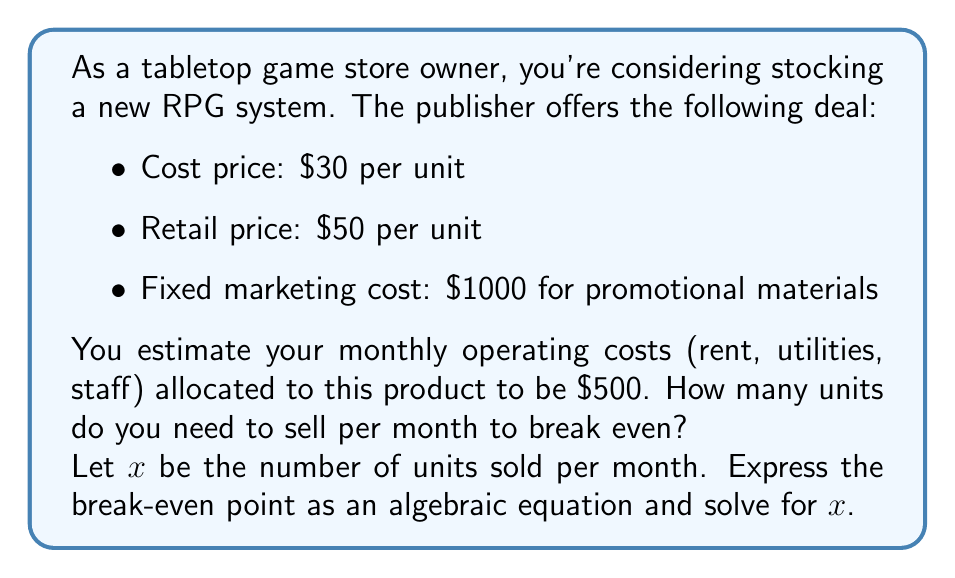Provide a solution to this math problem. To solve this problem, we need to set up an equation where total revenue equals total costs. Let's break it down step-by-step:

1. Revenue: 
   - Revenue per unit = $50
   - Total revenue = $50x$

2. Costs:
   - Variable cost per unit = $30
   - Total variable cost = $30x$
   - Fixed costs = $1000 (marketing) + $500 (monthly operating) = $1500$
   - Total costs = $30x + 1500$

3. Break-even equation:
   Revenue = Costs
   $$50x = 30x + 1500$$

4. Solve for $x$:
   $$50x - 30x = 1500$$
   $$20x = 1500$$
   $$x = \frac{1500}{20} = 75$$

Therefore, you need to sell 75 units per month to break even.

To verify:
- Revenue: $50 * 75 = $3750$
- Costs: $(30 * 75) + 1500 = $3750$

Revenue equals costs, confirming the break-even point.
Answer: The break-even point is 75 units per month. 